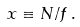<formula> <loc_0><loc_0><loc_500><loc_500>x \equiv N / f \, .</formula> 